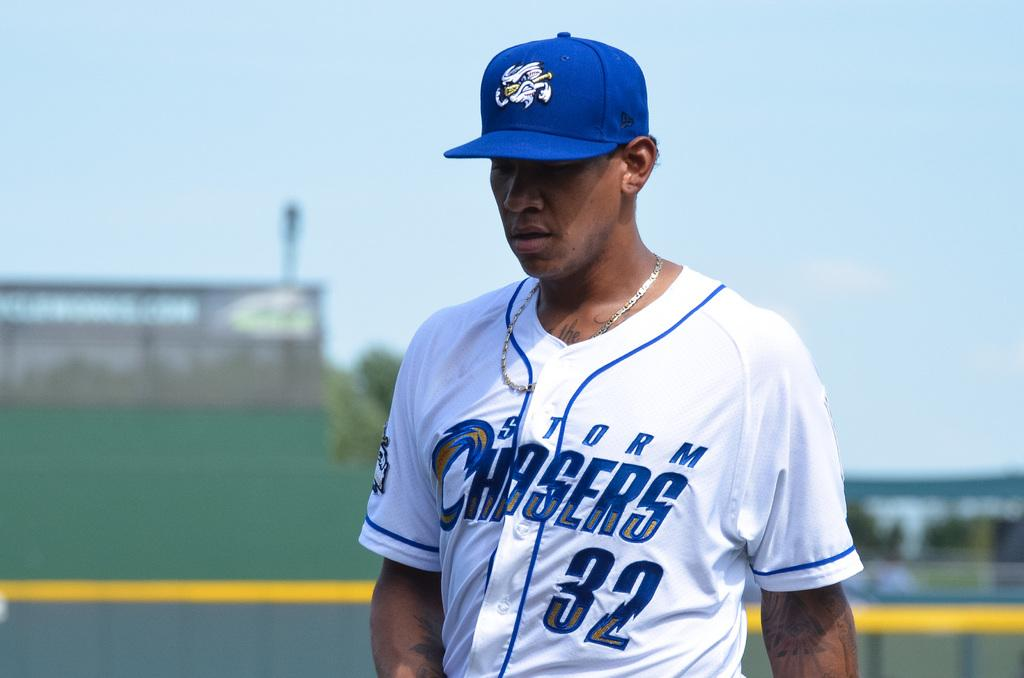<image>
Give a short and clear explanation of the subsequent image. A man in a white and blue Storm Chasers jersey 